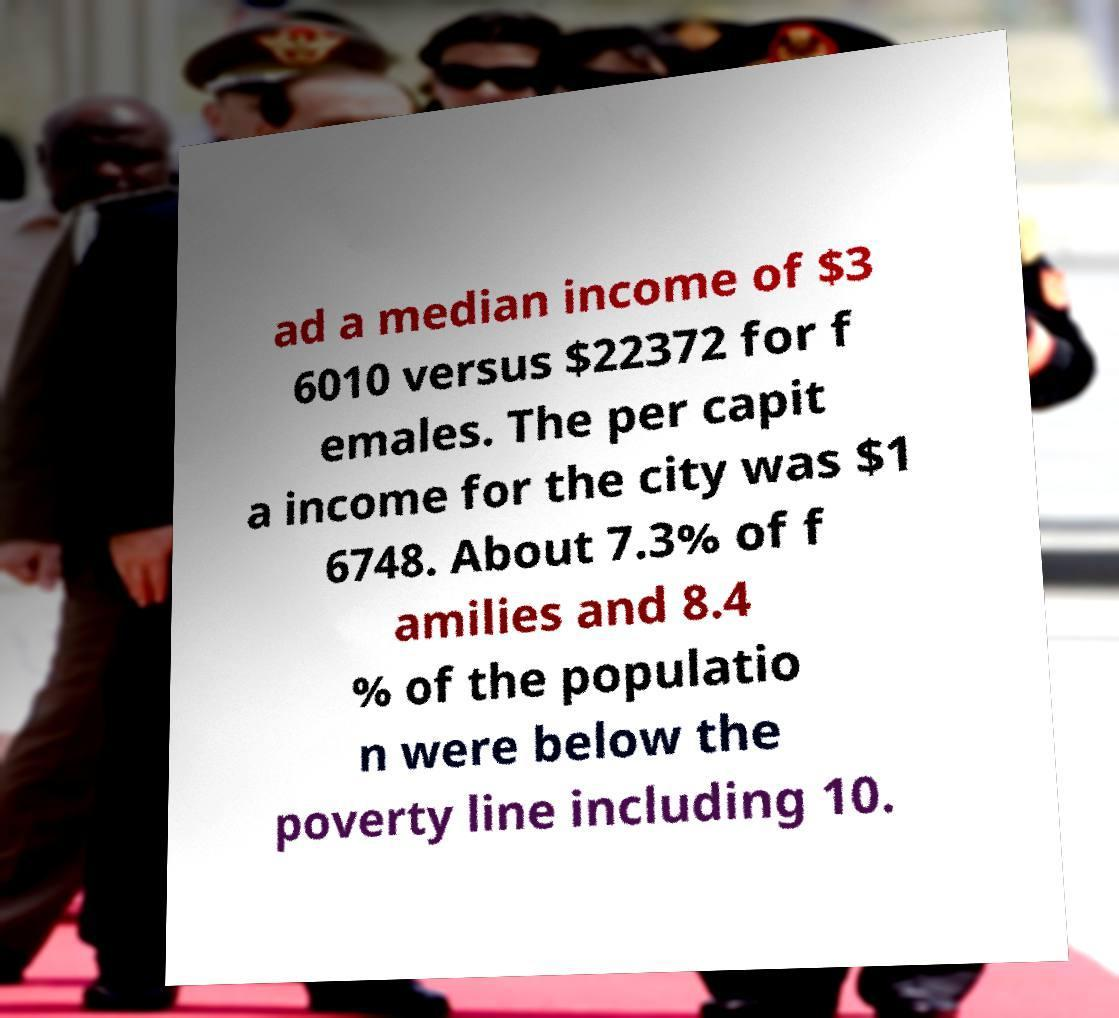I need the written content from this picture converted into text. Can you do that? ad a median income of $3 6010 versus $22372 for f emales. The per capit a income for the city was $1 6748. About 7.3% of f amilies and 8.4 % of the populatio n were below the poverty line including 10. 